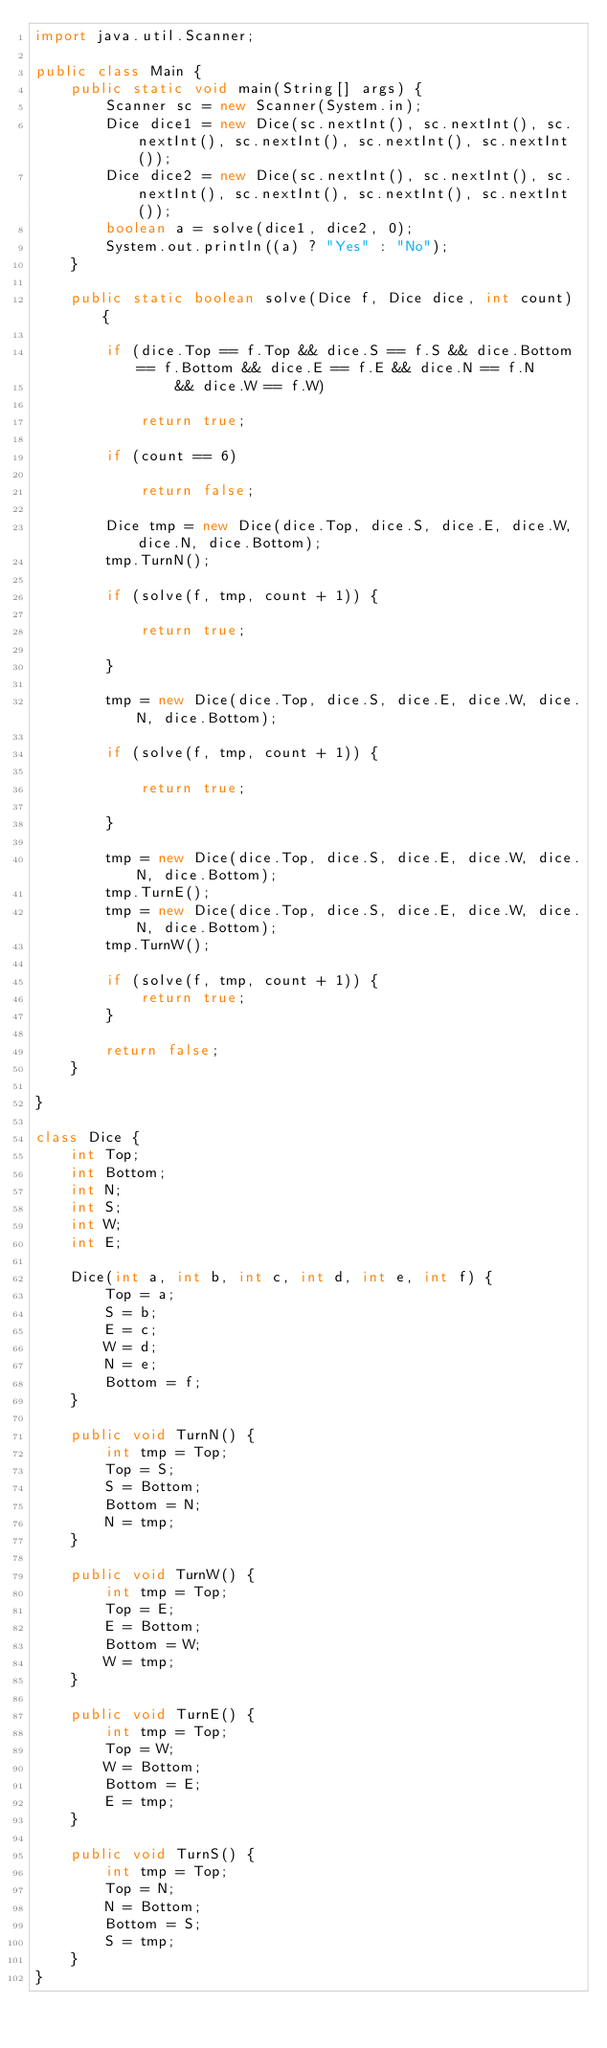<code> <loc_0><loc_0><loc_500><loc_500><_Java_>import java.util.Scanner;

public class Main {
	public static void main(String[] args) {
		Scanner sc = new Scanner(System.in);
		Dice dice1 = new Dice(sc.nextInt(), sc.nextInt(), sc.nextInt(), sc.nextInt(), sc.nextInt(), sc.nextInt());
		Dice dice2 = new Dice(sc.nextInt(), sc.nextInt(), sc.nextInt(), sc.nextInt(), sc.nextInt(), sc.nextInt());
		boolean a = solve(dice1, dice2, 0);
		System.out.println((a) ? "Yes" : "No");
	}

	public static boolean solve(Dice f, Dice dice, int count) {

		if (dice.Top == f.Top && dice.S == f.S && dice.Bottom == f.Bottom && dice.E == f.E && dice.N == f.N
				&& dice.W == f.W)

			return true;

		if (count == 6)

			return false;

		Dice tmp = new Dice(dice.Top, dice.S, dice.E, dice.W, dice.N, dice.Bottom);
		tmp.TurnN();

		if (solve(f, tmp, count + 1)) {

			return true;

		}

		tmp = new Dice(dice.Top, dice.S, dice.E, dice.W, dice.N, dice.Bottom);

		if (solve(f, tmp, count + 1)) {

			return true;

		}

		tmp = new Dice(dice.Top, dice.S, dice.E, dice.W, dice.N, dice.Bottom);
		tmp.TurnE();
		tmp = new Dice(dice.Top, dice.S, dice.E, dice.W, dice.N, dice.Bottom);
		tmp.TurnW();

		if (solve(f, tmp, count + 1)) {
			return true;
		}

		return false;
	}

}

class Dice {
	int Top;
	int Bottom;
	int N;
	int S;
	int W;
	int E;

	Dice(int a, int b, int c, int d, int e, int f) {
		Top = a;
		S = b;
		E = c;
		W = d;
		N = e;
		Bottom = f;
	}

	public void TurnN() {
		int tmp = Top;
		Top = S;
		S = Bottom;
		Bottom = N;
		N = tmp;
	}

	public void TurnW() {
		int tmp = Top;
		Top = E;
		E = Bottom;
		Bottom = W;
		W = tmp;
	}

	public void TurnE() {
		int tmp = Top;
		Top = W;
		W = Bottom;
		Bottom = E;
		E = tmp;
	}

	public void TurnS() {
		int tmp = Top;
		Top = N;
		N = Bottom;
		Bottom = S;
		S = tmp;
	}
}

</code> 